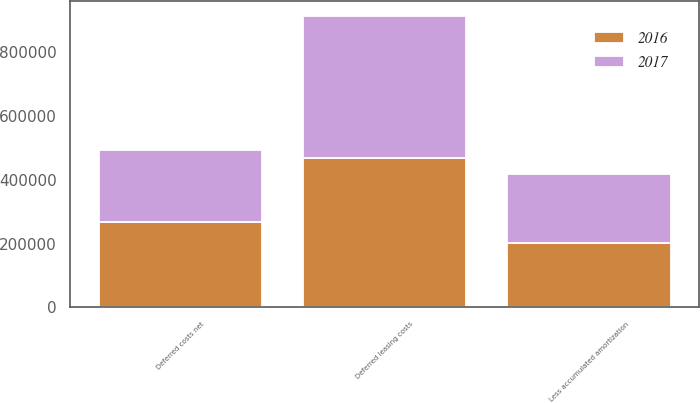<chart> <loc_0><loc_0><loc_500><loc_500><stacked_bar_chart><ecel><fcel>Deferred leasing costs<fcel>Less accumulated amortization<fcel>Deferred costs net<nl><fcel>2017<fcel>443341<fcel>217140<fcel>226201<nl><fcel>2016<fcel>468971<fcel>201371<fcel>267600<nl></chart> 